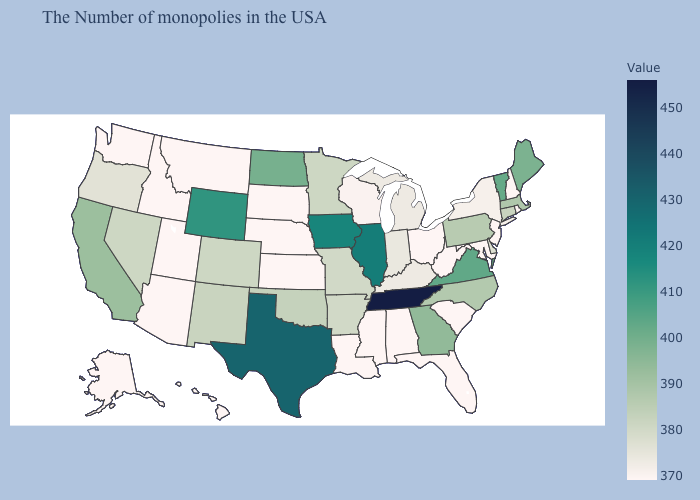Does Arizona have the lowest value in the USA?
Be succinct. Yes. Does California have the lowest value in the West?
Keep it brief. No. Among the states that border West Virginia , does Ohio have the lowest value?
Quick response, please. Yes. Among the states that border New Mexico , which have the highest value?
Be succinct. Texas. Does West Virginia have the highest value in the South?
Short answer required. No. Which states have the lowest value in the West?
Give a very brief answer. Utah, Montana, Arizona, Idaho, Washington, Alaska, Hawaii. Among the states that border Arizona , which have the lowest value?
Keep it brief. Utah. 